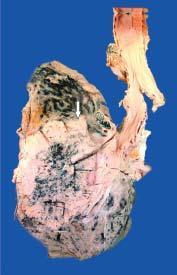what does sectioned surface show?
Answer the question using a single word or phrase. Grey-white fleshy tumour in the bronchus at its bifurcation 